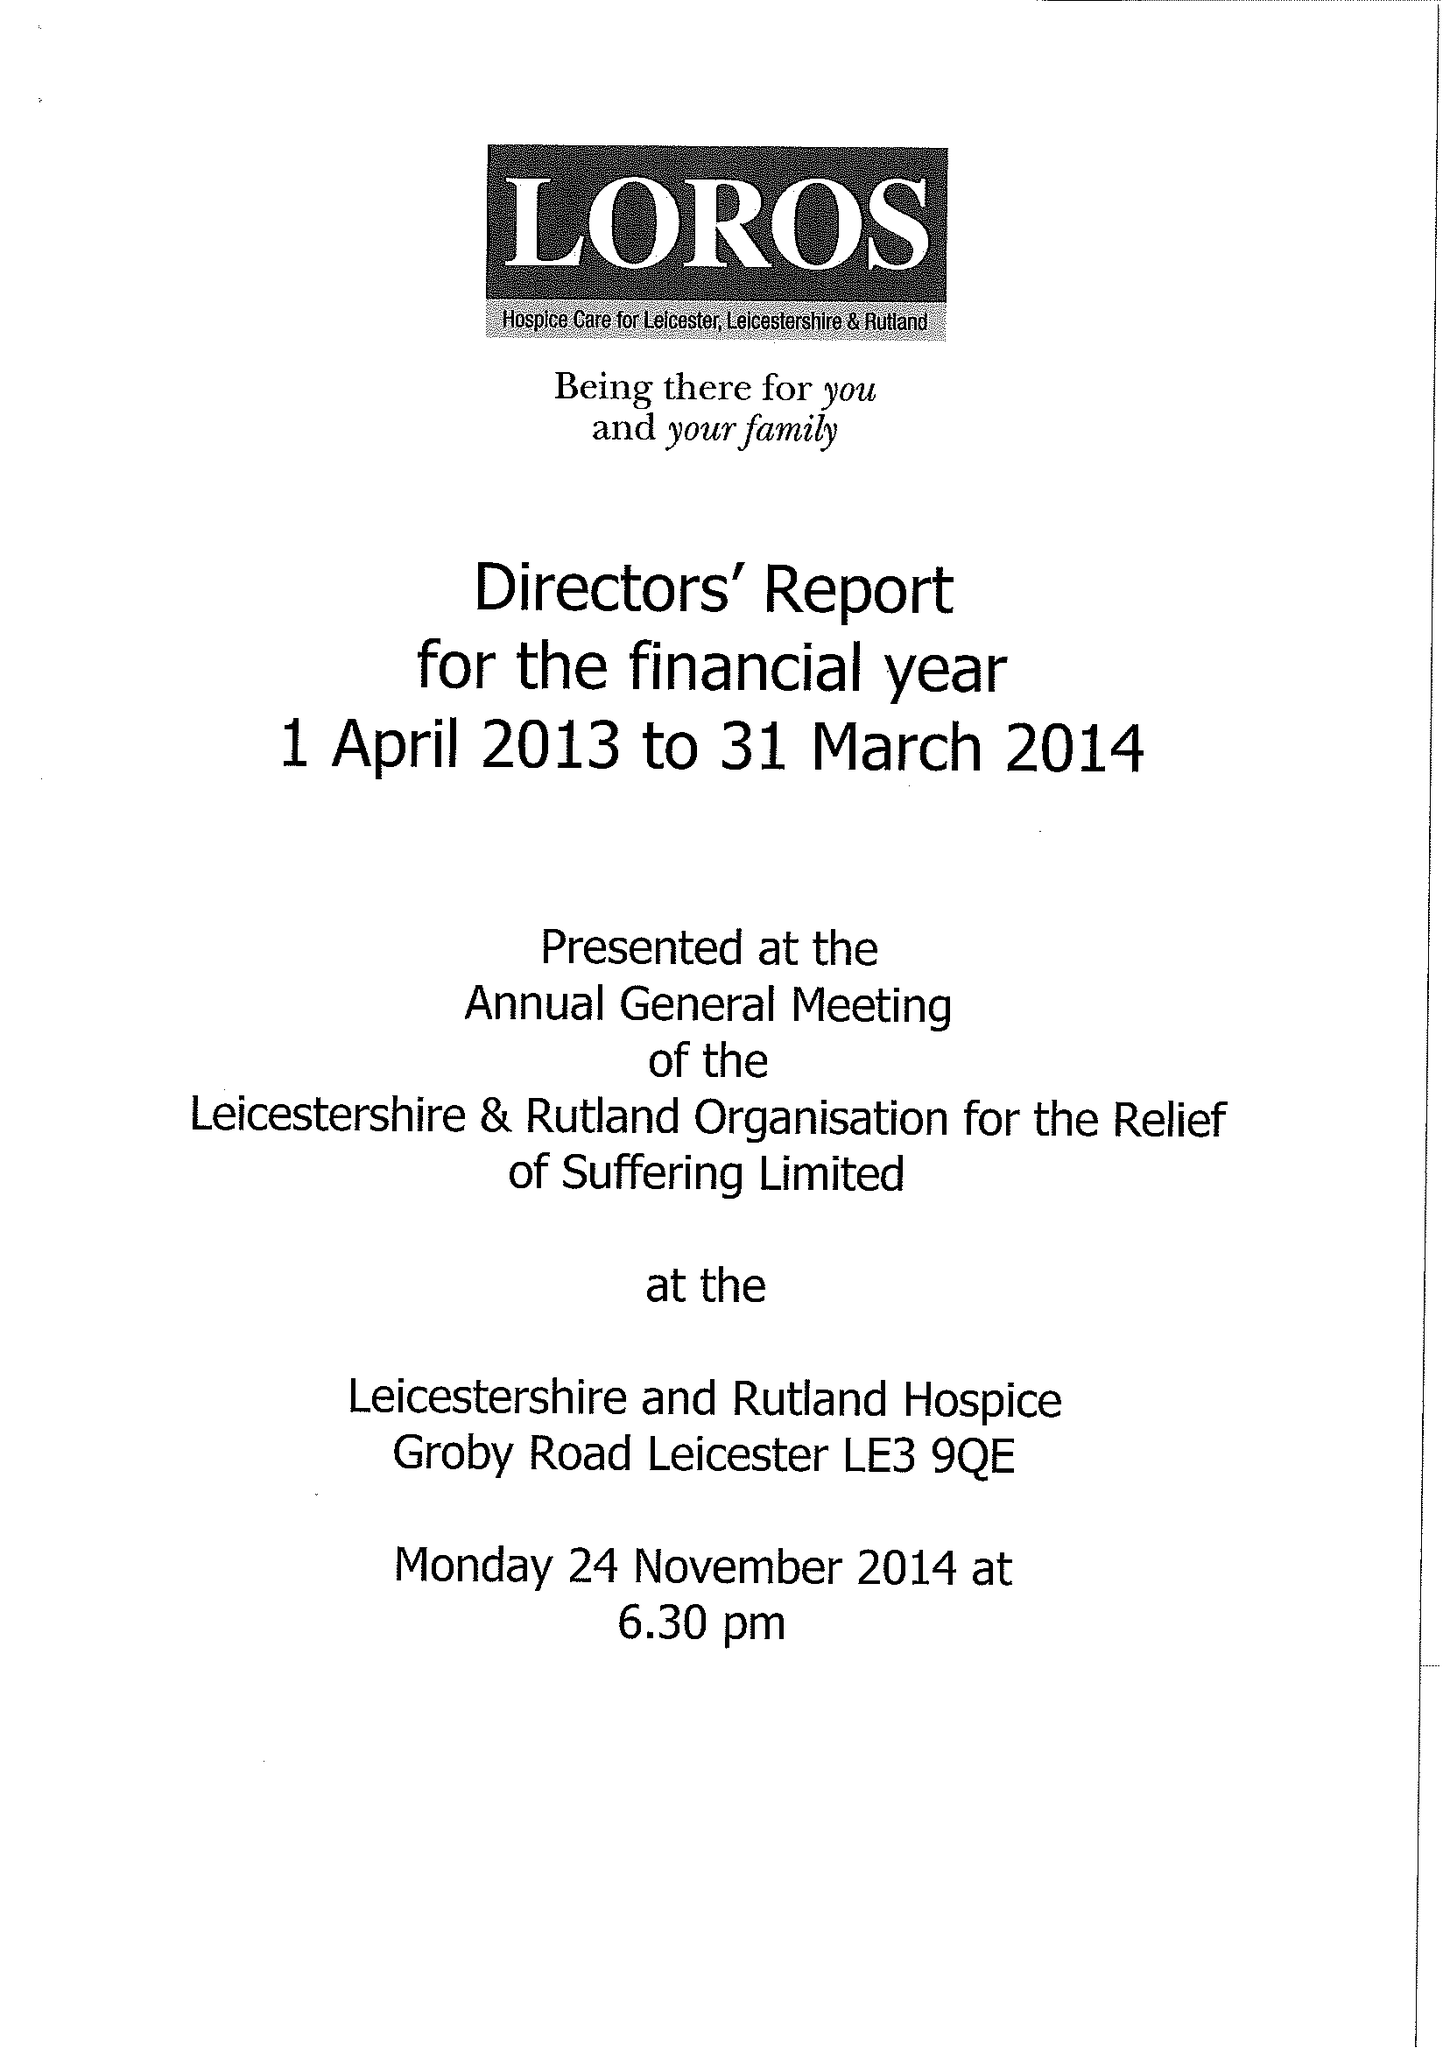What is the value for the address__street_line?
Answer the question using a single word or phrase. GROBY ROAD 